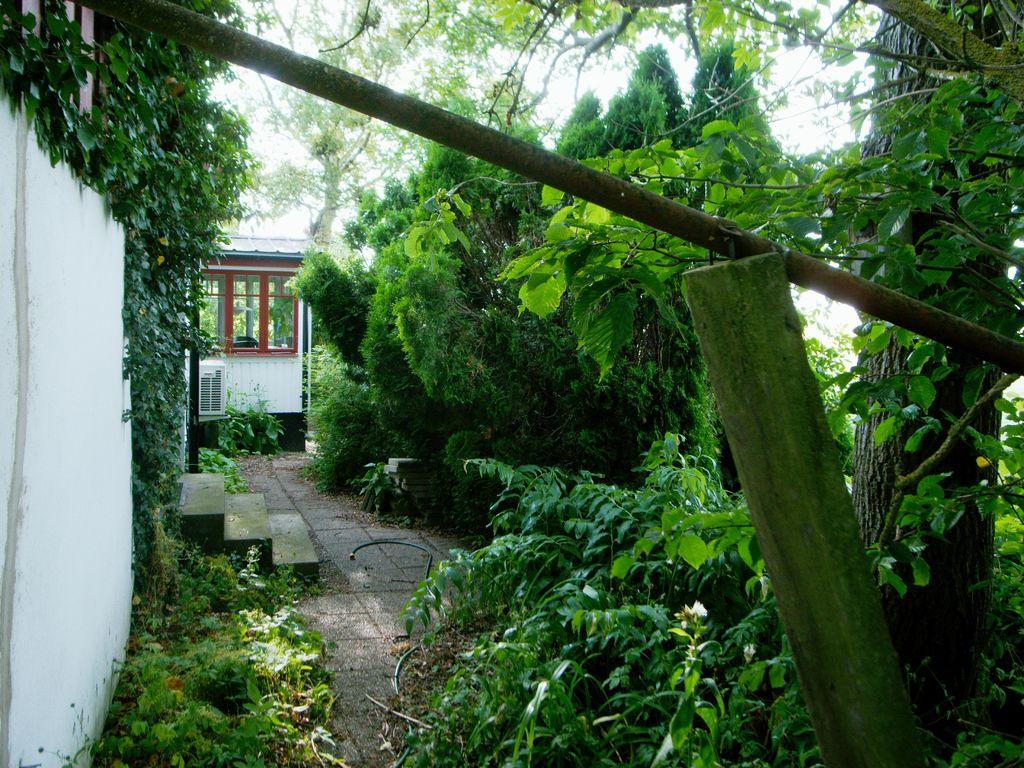What types of vegetation can be seen in the image? There are multiple plants and trees in the image. What structures are visible in the image? There are buildings visible in the image. What architectural feature is present in the center of the image? There are stairs in the center of the image. What objects are located in the front of the image? There are poles in the front of the image. What invention is being demonstrated by the pocket in the image? There is no invention or pocket present in the image. 